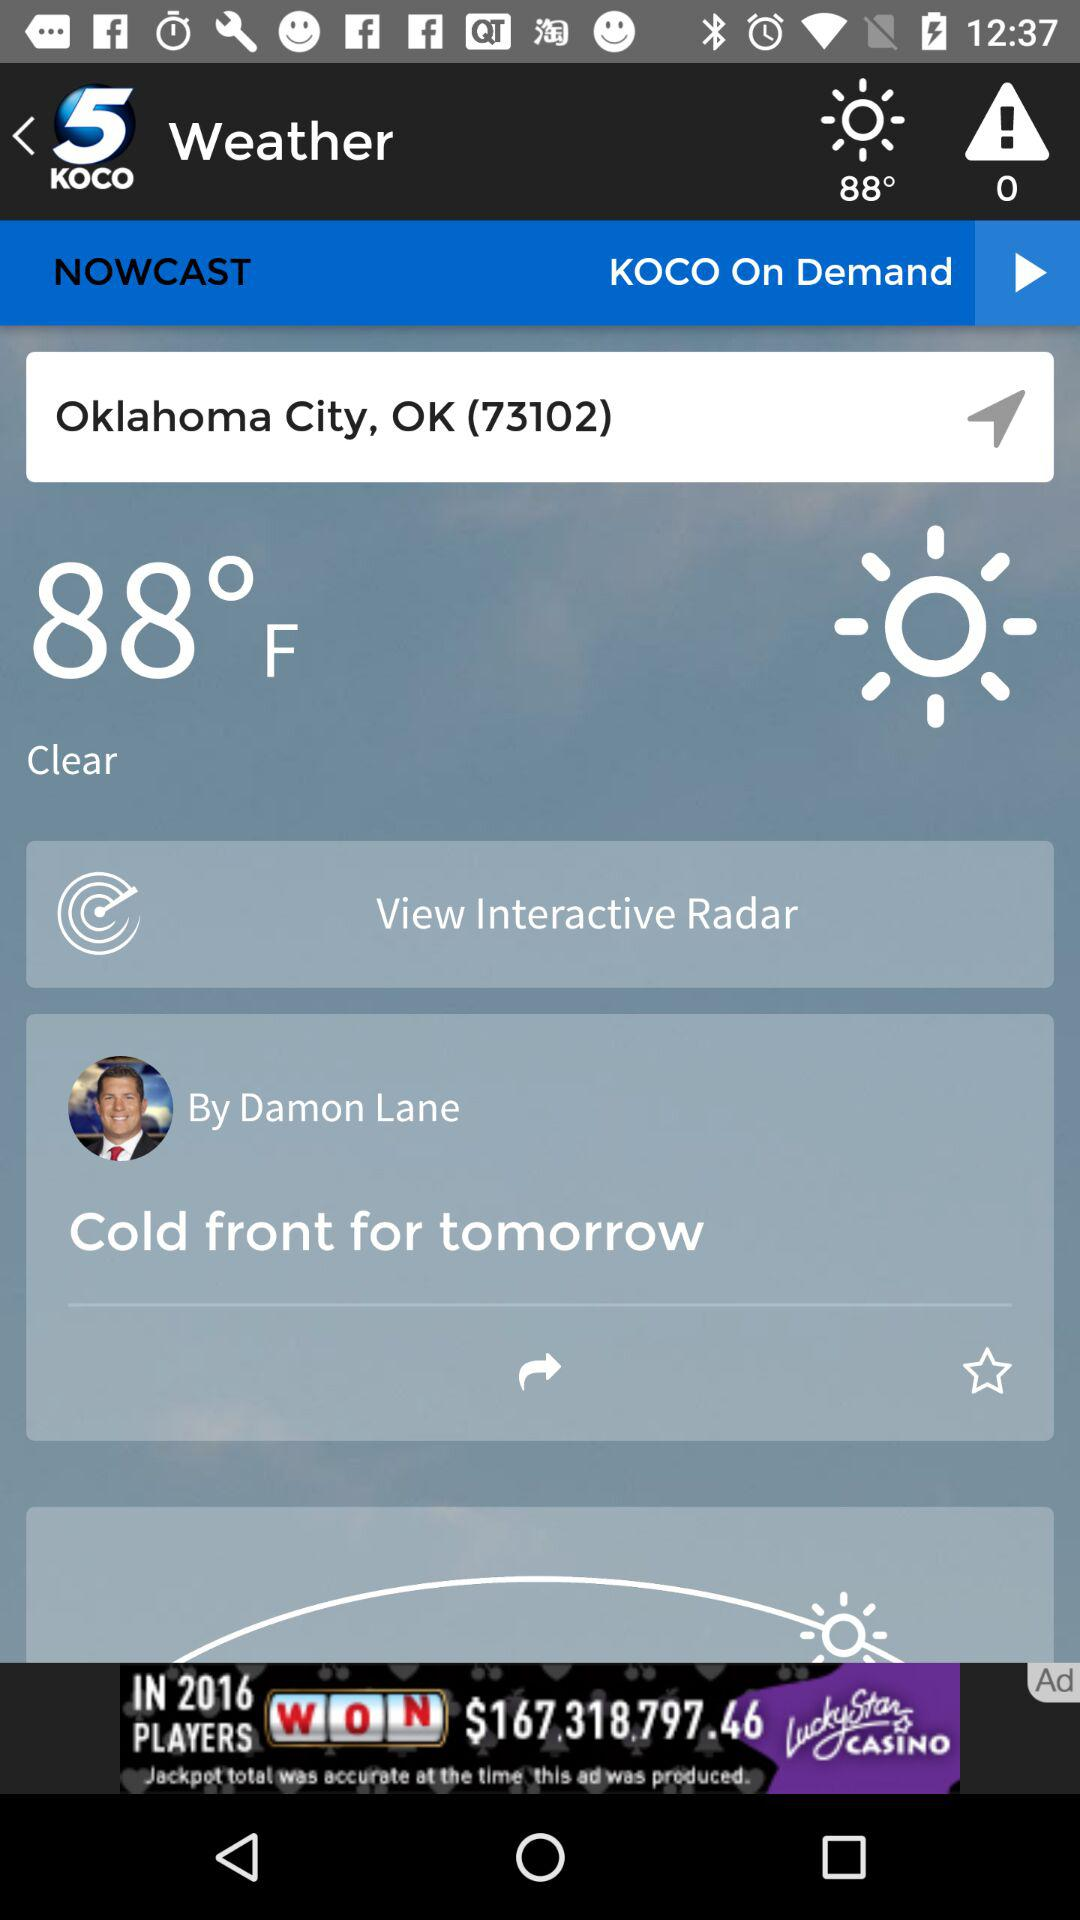Which city is given? The given city is Oklahoma City. 